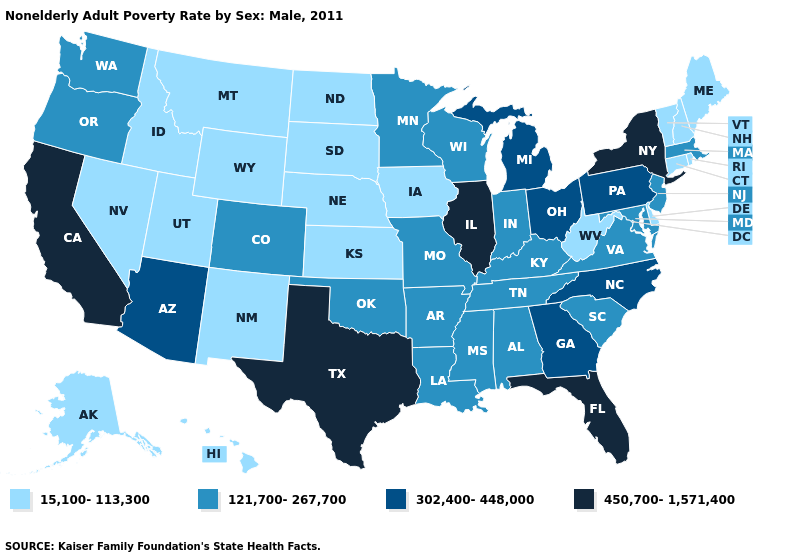What is the value of South Dakota?
Concise answer only. 15,100-113,300. What is the highest value in states that border West Virginia?
Keep it brief. 302,400-448,000. What is the value of Missouri?
Write a very short answer. 121,700-267,700. What is the value of Washington?
Concise answer only. 121,700-267,700. Which states have the highest value in the USA?
Write a very short answer. California, Florida, Illinois, New York, Texas. Name the states that have a value in the range 121,700-267,700?
Be succinct. Alabama, Arkansas, Colorado, Indiana, Kentucky, Louisiana, Maryland, Massachusetts, Minnesota, Mississippi, Missouri, New Jersey, Oklahoma, Oregon, South Carolina, Tennessee, Virginia, Washington, Wisconsin. Does Connecticut have the same value as Illinois?
Quick response, please. No. Does the first symbol in the legend represent the smallest category?
Answer briefly. Yes. Name the states that have a value in the range 450,700-1,571,400?
Give a very brief answer. California, Florida, Illinois, New York, Texas. Does Hawaii have the highest value in the USA?
Be succinct. No. What is the value of Georgia?
Answer briefly. 302,400-448,000. Does North Dakota have the lowest value in the USA?
Short answer required. Yes. Does Texas have the same value as Florida?
Answer briefly. Yes. Does South Carolina have the lowest value in the South?
Quick response, please. No. How many symbols are there in the legend?
Keep it brief. 4. 